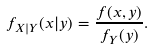Convert formula to latex. <formula><loc_0><loc_0><loc_500><loc_500>f _ { X | Y } ( x | y ) = \frac { f ( x , y ) } { f _ { Y } ( y ) } .</formula> 